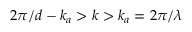Convert formula to latex. <formula><loc_0><loc_0><loc_500><loc_500>2 \pi / d - k _ { a } > k > k _ { a } = 2 \pi / \lambda</formula> 